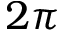Convert formula to latex. <formula><loc_0><loc_0><loc_500><loc_500>2 \pi</formula> 